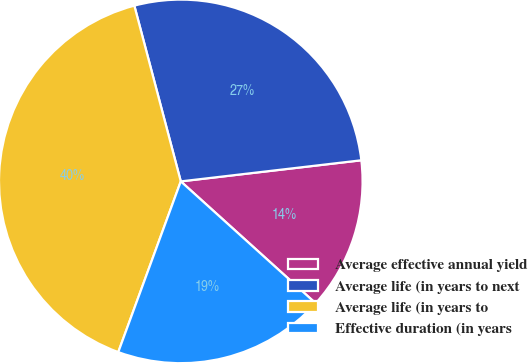<chart> <loc_0><loc_0><loc_500><loc_500><pie_chart><fcel>Average effective annual yield<fcel>Average life (in years to next<fcel>Average life (in years to<fcel>Effective duration (in years<nl><fcel>13.55%<fcel>27.26%<fcel>40.3%<fcel>18.89%<nl></chart> 